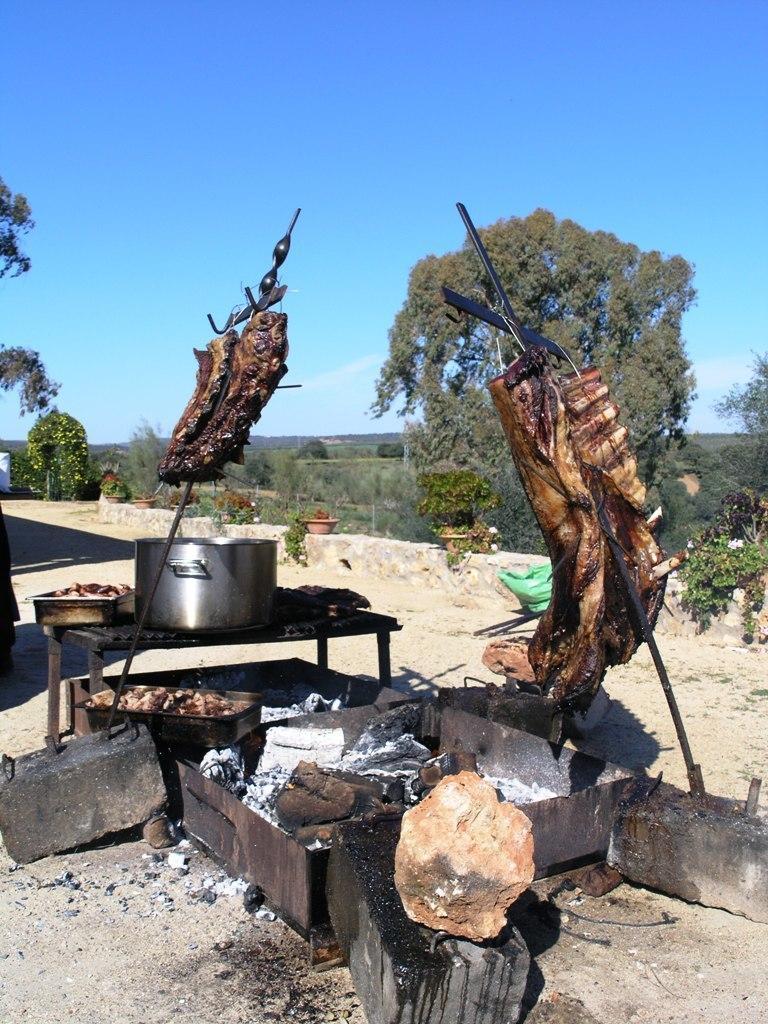What is being cooked in the image? Meat is cooking on coal in the image. What type of cooking utensil is present in the image? There is a pan in the image. What can be seen in the background of the image? Trees are visible in the image. What type of cherry is being used to flavor the meat in the image? There is no cherry present in the image, and therefore no flavoring can be observed. Where is the trip taking place in the image? There is no trip depicted in the image; it shows meat cooking on coal with a pan nearby. 